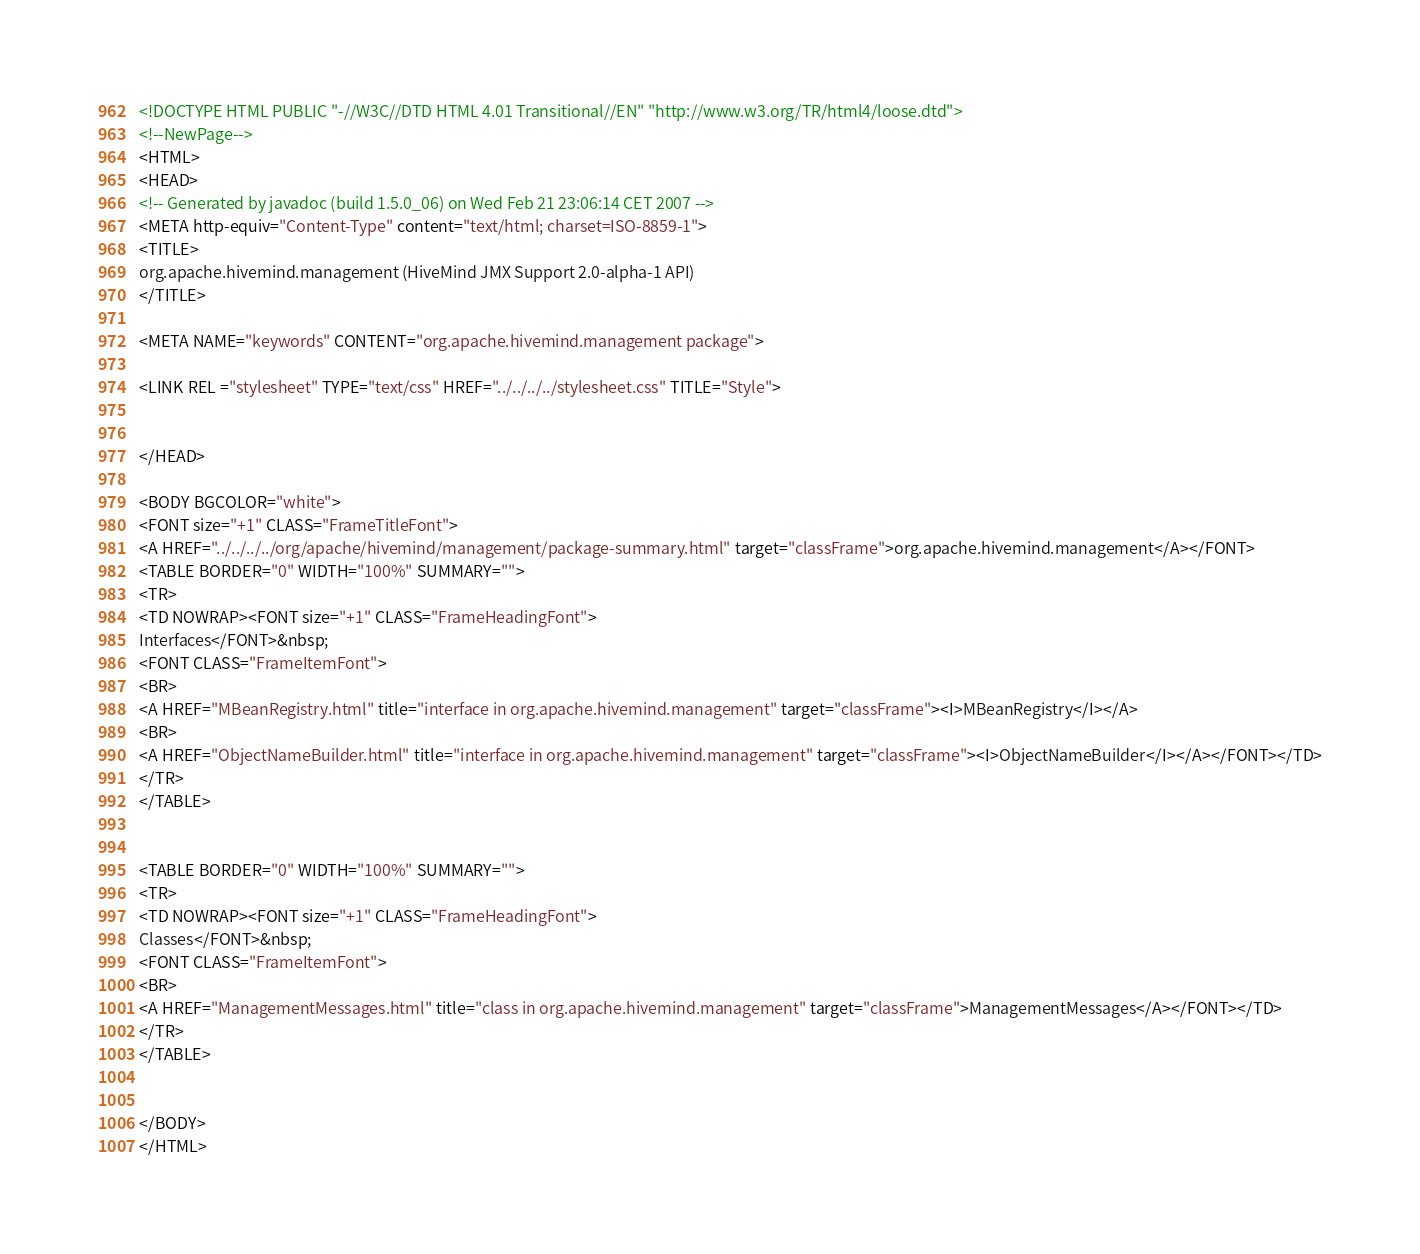<code> <loc_0><loc_0><loc_500><loc_500><_HTML_><!DOCTYPE HTML PUBLIC "-//W3C//DTD HTML 4.01 Transitional//EN" "http://www.w3.org/TR/html4/loose.dtd">
<!--NewPage-->
<HTML>
<HEAD>
<!-- Generated by javadoc (build 1.5.0_06) on Wed Feb 21 23:06:14 CET 2007 -->
<META http-equiv="Content-Type" content="text/html; charset=ISO-8859-1">
<TITLE>
org.apache.hivemind.management (HiveMind JMX Support 2.0-alpha-1 API)
</TITLE>

<META NAME="keywords" CONTENT="org.apache.hivemind.management package">

<LINK REL ="stylesheet" TYPE="text/css" HREF="../../../../stylesheet.css" TITLE="Style">


</HEAD>

<BODY BGCOLOR="white">
<FONT size="+1" CLASS="FrameTitleFont">
<A HREF="../../../../org/apache/hivemind/management/package-summary.html" target="classFrame">org.apache.hivemind.management</A></FONT>
<TABLE BORDER="0" WIDTH="100%" SUMMARY="">
<TR>
<TD NOWRAP><FONT size="+1" CLASS="FrameHeadingFont">
Interfaces</FONT>&nbsp;
<FONT CLASS="FrameItemFont">
<BR>
<A HREF="MBeanRegistry.html" title="interface in org.apache.hivemind.management" target="classFrame"><I>MBeanRegistry</I></A>
<BR>
<A HREF="ObjectNameBuilder.html" title="interface in org.apache.hivemind.management" target="classFrame"><I>ObjectNameBuilder</I></A></FONT></TD>
</TR>
</TABLE>


<TABLE BORDER="0" WIDTH="100%" SUMMARY="">
<TR>
<TD NOWRAP><FONT size="+1" CLASS="FrameHeadingFont">
Classes</FONT>&nbsp;
<FONT CLASS="FrameItemFont">
<BR>
<A HREF="ManagementMessages.html" title="class in org.apache.hivemind.management" target="classFrame">ManagementMessages</A></FONT></TD>
</TR>
</TABLE>


</BODY>
</HTML>
</code> 